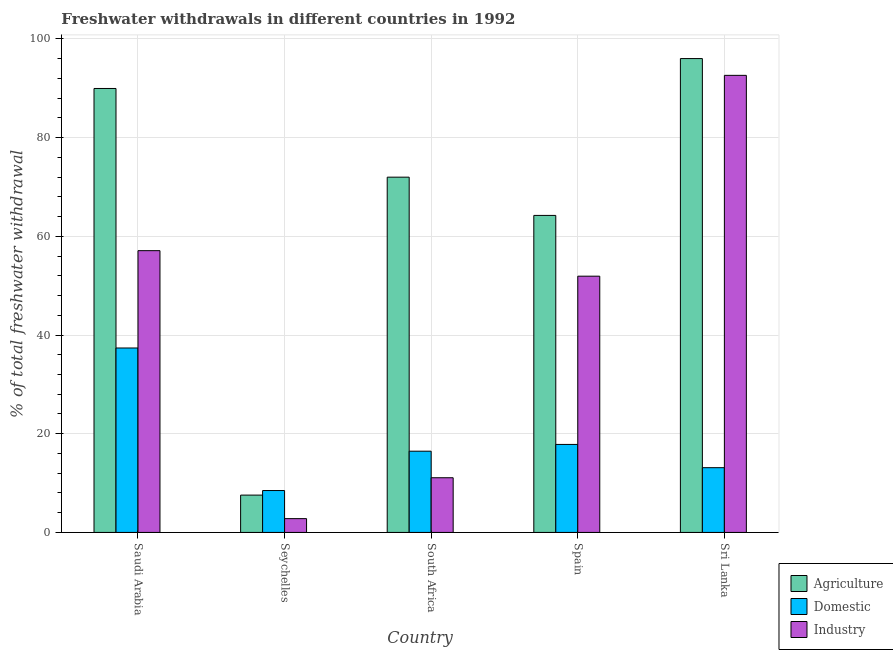How many different coloured bars are there?
Provide a succinct answer. 3. How many bars are there on the 4th tick from the left?
Offer a very short reply. 3. How many bars are there on the 2nd tick from the right?
Offer a terse response. 3. What is the label of the 1st group of bars from the left?
Keep it short and to the point. Saudi Arabia. What is the percentage of freshwater withdrawal for domestic purposes in Saudi Arabia?
Ensure brevity in your answer.  37.37. Across all countries, what is the maximum percentage of freshwater withdrawal for industry?
Offer a terse response. 92.61. Across all countries, what is the minimum percentage of freshwater withdrawal for domestic purposes?
Provide a short and direct response. 8.49. In which country was the percentage of freshwater withdrawal for industry maximum?
Ensure brevity in your answer.  Sri Lanka. In which country was the percentage of freshwater withdrawal for domestic purposes minimum?
Offer a terse response. Seychelles. What is the total percentage of freshwater withdrawal for agriculture in the graph?
Provide a succinct answer. 329.73. What is the difference between the percentage of freshwater withdrawal for industry in South Africa and that in Spain?
Ensure brevity in your answer.  -40.84. What is the difference between the percentage of freshwater withdrawal for industry in Saudi Arabia and the percentage of freshwater withdrawal for agriculture in South Africa?
Offer a terse response. -14.89. What is the average percentage of freshwater withdrawal for industry per country?
Offer a terse response. 43.1. What is the difference between the percentage of freshwater withdrawal for industry and percentage of freshwater withdrawal for domestic purposes in Saudi Arabia?
Provide a short and direct response. 19.72. In how many countries, is the percentage of freshwater withdrawal for industry greater than 60 %?
Ensure brevity in your answer.  1. What is the ratio of the percentage of freshwater withdrawal for domestic purposes in Spain to that in Sri Lanka?
Offer a terse response. 1.36. What is the difference between the highest and the second highest percentage of freshwater withdrawal for agriculture?
Keep it short and to the point. 6.06. What is the difference between the highest and the lowest percentage of freshwater withdrawal for industry?
Ensure brevity in your answer.  89.81. Is the sum of the percentage of freshwater withdrawal for domestic purposes in Saudi Arabia and Seychelles greater than the maximum percentage of freshwater withdrawal for industry across all countries?
Ensure brevity in your answer.  No. What does the 2nd bar from the left in South Africa represents?
Your answer should be compact. Domestic. What does the 3rd bar from the right in South Africa represents?
Your answer should be compact. Agriculture. Is it the case that in every country, the sum of the percentage of freshwater withdrawal for agriculture and percentage of freshwater withdrawal for domestic purposes is greater than the percentage of freshwater withdrawal for industry?
Keep it short and to the point. Yes. Are all the bars in the graph horizontal?
Ensure brevity in your answer.  No. How many countries are there in the graph?
Provide a succinct answer. 5. Are the values on the major ticks of Y-axis written in scientific E-notation?
Your answer should be very brief. No. Where does the legend appear in the graph?
Your answer should be compact. Bottom right. How many legend labels are there?
Provide a succinct answer. 3. How are the legend labels stacked?
Your answer should be very brief. Vertical. What is the title of the graph?
Provide a succinct answer. Freshwater withdrawals in different countries in 1992. What is the label or title of the X-axis?
Make the answer very short. Country. What is the label or title of the Y-axis?
Ensure brevity in your answer.  % of total freshwater withdrawal. What is the % of total freshwater withdrawal of Agriculture in Saudi Arabia?
Your answer should be very brief. 89.95. What is the % of total freshwater withdrawal in Domestic in Saudi Arabia?
Make the answer very short. 37.37. What is the % of total freshwater withdrawal in Industry in Saudi Arabia?
Your response must be concise. 57.09. What is the % of total freshwater withdrawal of Agriculture in Seychelles?
Your response must be concise. 7.56. What is the % of total freshwater withdrawal in Domestic in Seychelles?
Your response must be concise. 8.49. What is the % of total freshwater withdrawal in Industry in Seychelles?
Provide a short and direct response. 2.8. What is the % of total freshwater withdrawal of Agriculture in South Africa?
Keep it short and to the point. 71.98. What is the % of total freshwater withdrawal in Domestic in South Africa?
Keep it short and to the point. 16.46. What is the % of total freshwater withdrawal of Industry in South Africa?
Make the answer very short. 11.08. What is the % of total freshwater withdrawal of Agriculture in Spain?
Make the answer very short. 64.23. What is the % of total freshwater withdrawal of Domestic in Spain?
Provide a succinct answer. 17.83. What is the % of total freshwater withdrawal in Industry in Spain?
Give a very brief answer. 51.92. What is the % of total freshwater withdrawal in Agriculture in Sri Lanka?
Keep it short and to the point. 96.01. What is the % of total freshwater withdrawal of Domestic in Sri Lanka?
Your answer should be compact. 13.12. What is the % of total freshwater withdrawal of Industry in Sri Lanka?
Your response must be concise. 92.61. Across all countries, what is the maximum % of total freshwater withdrawal of Agriculture?
Your response must be concise. 96.01. Across all countries, what is the maximum % of total freshwater withdrawal in Domestic?
Offer a very short reply. 37.37. Across all countries, what is the maximum % of total freshwater withdrawal in Industry?
Provide a succinct answer. 92.61. Across all countries, what is the minimum % of total freshwater withdrawal of Agriculture?
Give a very brief answer. 7.56. Across all countries, what is the minimum % of total freshwater withdrawal of Domestic?
Make the answer very short. 8.49. Across all countries, what is the minimum % of total freshwater withdrawal of Industry?
Make the answer very short. 2.8. What is the total % of total freshwater withdrawal in Agriculture in the graph?
Your answer should be compact. 329.73. What is the total % of total freshwater withdrawal in Domestic in the graph?
Provide a short and direct response. 93.27. What is the total % of total freshwater withdrawal of Industry in the graph?
Keep it short and to the point. 215.5. What is the difference between the % of total freshwater withdrawal of Agriculture in Saudi Arabia and that in Seychelles?
Your answer should be very brief. 82.39. What is the difference between the % of total freshwater withdrawal of Domestic in Saudi Arabia and that in Seychelles?
Provide a succinct answer. 28.88. What is the difference between the % of total freshwater withdrawal in Industry in Saudi Arabia and that in Seychelles?
Give a very brief answer. 54.29. What is the difference between the % of total freshwater withdrawal of Agriculture in Saudi Arabia and that in South Africa?
Offer a terse response. 17.97. What is the difference between the % of total freshwater withdrawal of Domestic in Saudi Arabia and that in South Africa?
Your response must be concise. 20.91. What is the difference between the % of total freshwater withdrawal in Industry in Saudi Arabia and that in South Africa?
Keep it short and to the point. 46.01. What is the difference between the % of total freshwater withdrawal of Agriculture in Saudi Arabia and that in Spain?
Offer a terse response. 25.72. What is the difference between the % of total freshwater withdrawal of Domestic in Saudi Arabia and that in Spain?
Keep it short and to the point. 19.54. What is the difference between the % of total freshwater withdrawal in Industry in Saudi Arabia and that in Spain?
Ensure brevity in your answer.  5.17. What is the difference between the % of total freshwater withdrawal in Agriculture in Saudi Arabia and that in Sri Lanka?
Give a very brief answer. -6.06. What is the difference between the % of total freshwater withdrawal in Domestic in Saudi Arabia and that in Sri Lanka?
Your answer should be very brief. 24.25. What is the difference between the % of total freshwater withdrawal of Industry in Saudi Arabia and that in Sri Lanka?
Keep it short and to the point. -35.52. What is the difference between the % of total freshwater withdrawal in Agriculture in Seychelles and that in South Africa?
Provide a succinct answer. -64.42. What is the difference between the % of total freshwater withdrawal of Domestic in Seychelles and that in South Africa?
Provide a succinct answer. -7.97. What is the difference between the % of total freshwater withdrawal in Industry in Seychelles and that in South Africa?
Ensure brevity in your answer.  -8.28. What is the difference between the % of total freshwater withdrawal of Agriculture in Seychelles and that in Spain?
Ensure brevity in your answer.  -56.67. What is the difference between the % of total freshwater withdrawal in Domestic in Seychelles and that in Spain?
Give a very brief answer. -9.34. What is the difference between the % of total freshwater withdrawal in Industry in Seychelles and that in Spain?
Make the answer very short. -49.12. What is the difference between the % of total freshwater withdrawal in Agriculture in Seychelles and that in Sri Lanka?
Provide a short and direct response. -88.45. What is the difference between the % of total freshwater withdrawal of Domestic in Seychelles and that in Sri Lanka?
Give a very brief answer. -4.63. What is the difference between the % of total freshwater withdrawal of Industry in Seychelles and that in Sri Lanka?
Give a very brief answer. -89.81. What is the difference between the % of total freshwater withdrawal in Agriculture in South Africa and that in Spain?
Provide a succinct answer. 7.75. What is the difference between the % of total freshwater withdrawal of Domestic in South Africa and that in Spain?
Your response must be concise. -1.37. What is the difference between the % of total freshwater withdrawal in Industry in South Africa and that in Spain?
Your answer should be very brief. -40.84. What is the difference between the % of total freshwater withdrawal in Agriculture in South Africa and that in Sri Lanka?
Your answer should be very brief. -24.03. What is the difference between the % of total freshwater withdrawal in Domestic in South Africa and that in Sri Lanka?
Your response must be concise. 3.34. What is the difference between the % of total freshwater withdrawal of Industry in South Africa and that in Sri Lanka?
Provide a short and direct response. -81.53. What is the difference between the % of total freshwater withdrawal of Agriculture in Spain and that in Sri Lanka?
Your answer should be compact. -31.78. What is the difference between the % of total freshwater withdrawal in Domestic in Spain and that in Sri Lanka?
Your answer should be compact. 4.71. What is the difference between the % of total freshwater withdrawal of Industry in Spain and that in Sri Lanka?
Keep it short and to the point. -40.69. What is the difference between the % of total freshwater withdrawal in Agriculture in Saudi Arabia and the % of total freshwater withdrawal in Domestic in Seychelles?
Offer a terse response. 81.46. What is the difference between the % of total freshwater withdrawal in Agriculture in Saudi Arabia and the % of total freshwater withdrawal in Industry in Seychelles?
Make the answer very short. 87.15. What is the difference between the % of total freshwater withdrawal of Domestic in Saudi Arabia and the % of total freshwater withdrawal of Industry in Seychelles?
Give a very brief answer. 34.57. What is the difference between the % of total freshwater withdrawal in Agriculture in Saudi Arabia and the % of total freshwater withdrawal in Domestic in South Africa?
Your answer should be very brief. 73.49. What is the difference between the % of total freshwater withdrawal of Agriculture in Saudi Arabia and the % of total freshwater withdrawal of Industry in South Africa?
Give a very brief answer. 78.87. What is the difference between the % of total freshwater withdrawal of Domestic in Saudi Arabia and the % of total freshwater withdrawal of Industry in South Africa?
Keep it short and to the point. 26.29. What is the difference between the % of total freshwater withdrawal in Agriculture in Saudi Arabia and the % of total freshwater withdrawal in Domestic in Spain?
Ensure brevity in your answer.  72.12. What is the difference between the % of total freshwater withdrawal of Agriculture in Saudi Arabia and the % of total freshwater withdrawal of Industry in Spain?
Your answer should be very brief. 38.03. What is the difference between the % of total freshwater withdrawal of Domestic in Saudi Arabia and the % of total freshwater withdrawal of Industry in Spain?
Provide a short and direct response. -14.55. What is the difference between the % of total freshwater withdrawal in Agriculture in Saudi Arabia and the % of total freshwater withdrawal in Domestic in Sri Lanka?
Offer a terse response. 76.83. What is the difference between the % of total freshwater withdrawal of Agriculture in Saudi Arabia and the % of total freshwater withdrawal of Industry in Sri Lanka?
Offer a very short reply. -2.66. What is the difference between the % of total freshwater withdrawal of Domestic in Saudi Arabia and the % of total freshwater withdrawal of Industry in Sri Lanka?
Offer a terse response. -55.24. What is the difference between the % of total freshwater withdrawal of Agriculture in Seychelles and the % of total freshwater withdrawal of Domestic in South Africa?
Offer a very short reply. -8.9. What is the difference between the % of total freshwater withdrawal of Agriculture in Seychelles and the % of total freshwater withdrawal of Industry in South Africa?
Make the answer very short. -3.52. What is the difference between the % of total freshwater withdrawal of Domestic in Seychelles and the % of total freshwater withdrawal of Industry in South Africa?
Your response must be concise. -2.59. What is the difference between the % of total freshwater withdrawal in Agriculture in Seychelles and the % of total freshwater withdrawal in Domestic in Spain?
Your answer should be compact. -10.27. What is the difference between the % of total freshwater withdrawal in Agriculture in Seychelles and the % of total freshwater withdrawal in Industry in Spain?
Give a very brief answer. -44.36. What is the difference between the % of total freshwater withdrawal in Domestic in Seychelles and the % of total freshwater withdrawal in Industry in Spain?
Keep it short and to the point. -43.43. What is the difference between the % of total freshwater withdrawal in Agriculture in Seychelles and the % of total freshwater withdrawal in Domestic in Sri Lanka?
Keep it short and to the point. -5.56. What is the difference between the % of total freshwater withdrawal in Agriculture in Seychelles and the % of total freshwater withdrawal in Industry in Sri Lanka?
Your answer should be compact. -85.05. What is the difference between the % of total freshwater withdrawal in Domestic in Seychelles and the % of total freshwater withdrawal in Industry in Sri Lanka?
Offer a terse response. -84.12. What is the difference between the % of total freshwater withdrawal in Agriculture in South Africa and the % of total freshwater withdrawal in Domestic in Spain?
Offer a terse response. 54.15. What is the difference between the % of total freshwater withdrawal of Agriculture in South Africa and the % of total freshwater withdrawal of Industry in Spain?
Offer a terse response. 20.06. What is the difference between the % of total freshwater withdrawal in Domestic in South Africa and the % of total freshwater withdrawal in Industry in Spain?
Offer a very short reply. -35.46. What is the difference between the % of total freshwater withdrawal of Agriculture in South Africa and the % of total freshwater withdrawal of Domestic in Sri Lanka?
Provide a succinct answer. 58.86. What is the difference between the % of total freshwater withdrawal in Agriculture in South Africa and the % of total freshwater withdrawal in Industry in Sri Lanka?
Your response must be concise. -20.63. What is the difference between the % of total freshwater withdrawal of Domestic in South Africa and the % of total freshwater withdrawal of Industry in Sri Lanka?
Give a very brief answer. -76.15. What is the difference between the % of total freshwater withdrawal in Agriculture in Spain and the % of total freshwater withdrawal in Domestic in Sri Lanka?
Keep it short and to the point. 51.11. What is the difference between the % of total freshwater withdrawal of Agriculture in Spain and the % of total freshwater withdrawal of Industry in Sri Lanka?
Offer a terse response. -28.38. What is the difference between the % of total freshwater withdrawal in Domestic in Spain and the % of total freshwater withdrawal in Industry in Sri Lanka?
Keep it short and to the point. -74.78. What is the average % of total freshwater withdrawal in Agriculture per country?
Keep it short and to the point. 65.95. What is the average % of total freshwater withdrawal in Domestic per country?
Provide a short and direct response. 18.65. What is the average % of total freshwater withdrawal in Industry per country?
Keep it short and to the point. 43.1. What is the difference between the % of total freshwater withdrawal in Agriculture and % of total freshwater withdrawal in Domestic in Saudi Arabia?
Give a very brief answer. 52.58. What is the difference between the % of total freshwater withdrawal of Agriculture and % of total freshwater withdrawal of Industry in Saudi Arabia?
Provide a short and direct response. 32.86. What is the difference between the % of total freshwater withdrawal of Domestic and % of total freshwater withdrawal of Industry in Saudi Arabia?
Ensure brevity in your answer.  -19.72. What is the difference between the % of total freshwater withdrawal in Agriculture and % of total freshwater withdrawal in Domestic in Seychelles?
Give a very brief answer. -0.93. What is the difference between the % of total freshwater withdrawal in Agriculture and % of total freshwater withdrawal in Industry in Seychelles?
Provide a short and direct response. 4.77. What is the difference between the % of total freshwater withdrawal in Domestic and % of total freshwater withdrawal in Industry in Seychelles?
Make the answer very short. 5.69. What is the difference between the % of total freshwater withdrawal of Agriculture and % of total freshwater withdrawal of Domestic in South Africa?
Your answer should be very brief. 55.52. What is the difference between the % of total freshwater withdrawal of Agriculture and % of total freshwater withdrawal of Industry in South Africa?
Give a very brief answer. 60.9. What is the difference between the % of total freshwater withdrawal in Domestic and % of total freshwater withdrawal in Industry in South Africa?
Offer a terse response. 5.38. What is the difference between the % of total freshwater withdrawal in Agriculture and % of total freshwater withdrawal in Domestic in Spain?
Give a very brief answer. 46.4. What is the difference between the % of total freshwater withdrawal in Agriculture and % of total freshwater withdrawal in Industry in Spain?
Offer a very short reply. 12.31. What is the difference between the % of total freshwater withdrawal in Domestic and % of total freshwater withdrawal in Industry in Spain?
Make the answer very short. -34.09. What is the difference between the % of total freshwater withdrawal of Agriculture and % of total freshwater withdrawal of Domestic in Sri Lanka?
Ensure brevity in your answer.  82.89. What is the difference between the % of total freshwater withdrawal of Domestic and % of total freshwater withdrawal of Industry in Sri Lanka?
Provide a short and direct response. -79.49. What is the ratio of the % of total freshwater withdrawal of Agriculture in Saudi Arabia to that in Seychelles?
Your answer should be very brief. 11.89. What is the ratio of the % of total freshwater withdrawal in Domestic in Saudi Arabia to that in Seychelles?
Your response must be concise. 4.4. What is the ratio of the % of total freshwater withdrawal of Industry in Saudi Arabia to that in Seychelles?
Provide a succinct answer. 20.41. What is the ratio of the % of total freshwater withdrawal of Agriculture in Saudi Arabia to that in South Africa?
Ensure brevity in your answer.  1.25. What is the ratio of the % of total freshwater withdrawal of Domestic in Saudi Arabia to that in South Africa?
Your response must be concise. 2.27. What is the ratio of the % of total freshwater withdrawal of Industry in Saudi Arabia to that in South Africa?
Your answer should be very brief. 5.15. What is the ratio of the % of total freshwater withdrawal of Agriculture in Saudi Arabia to that in Spain?
Provide a short and direct response. 1.4. What is the ratio of the % of total freshwater withdrawal in Domestic in Saudi Arabia to that in Spain?
Provide a succinct answer. 2.1. What is the ratio of the % of total freshwater withdrawal of Industry in Saudi Arabia to that in Spain?
Keep it short and to the point. 1.1. What is the ratio of the % of total freshwater withdrawal in Agriculture in Saudi Arabia to that in Sri Lanka?
Keep it short and to the point. 0.94. What is the ratio of the % of total freshwater withdrawal in Domestic in Saudi Arabia to that in Sri Lanka?
Make the answer very short. 2.85. What is the ratio of the % of total freshwater withdrawal of Industry in Saudi Arabia to that in Sri Lanka?
Offer a very short reply. 0.62. What is the ratio of the % of total freshwater withdrawal in Agriculture in Seychelles to that in South Africa?
Offer a terse response. 0.11. What is the ratio of the % of total freshwater withdrawal of Domestic in Seychelles to that in South Africa?
Offer a very short reply. 0.52. What is the ratio of the % of total freshwater withdrawal of Industry in Seychelles to that in South Africa?
Keep it short and to the point. 0.25. What is the ratio of the % of total freshwater withdrawal of Agriculture in Seychelles to that in Spain?
Provide a succinct answer. 0.12. What is the ratio of the % of total freshwater withdrawal in Domestic in Seychelles to that in Spain?
Provide a short and direct response. 0.48. What is the ratio of the % of total freshwater withdrawal in Industry in Seychelles to that in Spain?
Ensure brevity in your answer.  0.05. What is the ratio of the % of total freshwater withdrawal in Agriculture in Seychelles to that in Sri Lanka?
Give a very brief answer. 0.08. What is the ratio of the % of total freshwater withdrawal in Domestic in Seychelles to that in Sri Lanka?
Ensure brevity in your answer.  0.65. What is the ratio of the % of total freshwater withdrawal in Industry in Seychelles to that in Sri Lanka?
Your response must be concise. 0.03. What is the ratio of the % of total freshwater withdrawal of Agriculture in South Africa to that in Spain?
Your response must be concise. 1.12. What is the ratio of the % of total freshwater withdrawal of Domestic in South Africa to that in Spain?
Give a very brief answer. 0.92. What is the ratio of the % of total freshwater withdrawal of Industry in South Africa to that in Spain?
Make the answer very short. 0.21. What is the ratio of the % of total freshwater withdrawal of Agriculture in South Africa to that in Sri Lanka?
Provide a short and direct response. 0.75. What is the ratio of the % of total freshwater withdrawal of Domestic in South Africa to that in Sri Lanka?
Ensure brevity in your answer.  1.25. What is the ratio of the % of total freshwater withdrawal in Industry in South Africa to that in Sri Lanka?
Give a very brief answer. 0.12. What is the ratio of the % of total freshwater withdrawal of Agriculture in Spain to that in Sri Lanka?
Ensure brevity in your answer.  0.67. What is the ratio of the % of total freshwater withdrawal in Domestic in Spain to that in Sri Lanka?
Offer a very short reply. 1.36. What is the ratio of the % of total freshwater withdrawal in Industry in Spain to that in Sri Lanka?
Give a very brief answer. 0.56. What is the difference between the highest and the second highest % of total freshwater withdrawal in Agriculture?
Your answer should be very brief. 6.06. What is the difference between the highest and the second highest % of total freshwater withdrawal in Domestic?
Your response must be concise. 19.54. What is the difference between the highest and the second highest % of total freshwater withdrawal of Industry?
Keep it short and to the point. 35.52. What is the difference between the highest and the lowest % of total freshwater withdrawal in Agriculture?
Your response must be concise. 88.45. What is the difference between the highest and the lowest % of total freshwater withdrawal of Domestic?
Make the answer very short. 28.88. What is the difference between the highest and the lowest % of total freshwater withdrawal in Industry?
Your answer should be compact. 89.81. 